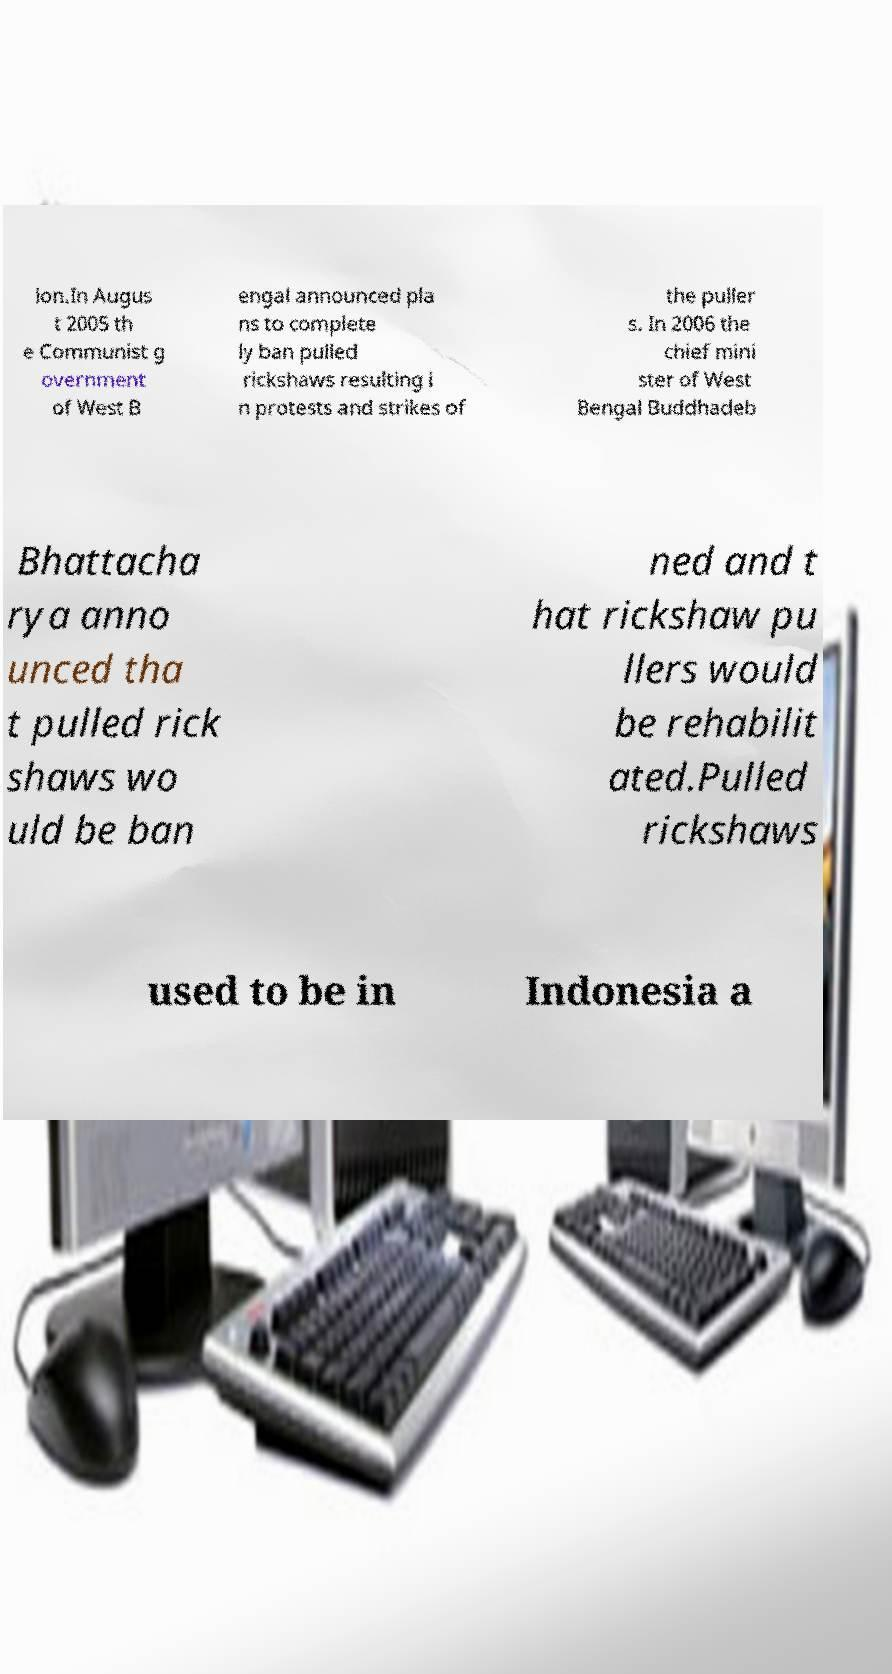For documentation purposes, I need the text within this image transcribed. Could you provide that? ion.In Augus t 2005 th e Communist g overnment of West B engal announced pla ns to complete ly ban pulled rickshaws resulting i n protests and strikes of the puller s. In 2006 the chief mini ster of West Bengal Buddhadeb Bhattacha rya anno unced tha t pulled rick shaws wo uld be ban ned and t hat rickshaw pu llers would be rehabilit ated.Pulled rickshaws used to be in Indonesia a 